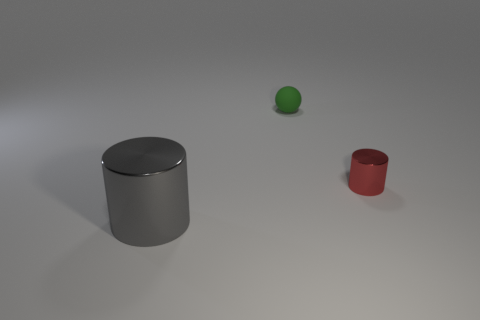What is the shape of the green matte object that is the same size as the red cylinder?
Provide a succinct answer. Sphere. The tiny thing that is the same material as the large cylinder is what color?
Your answer should be compact. Red. What is the size of the other gray metal thing that is the same shape as the small shiny thing?
Offer a very short reply. Large. Are there any other things that have the same size as the gray metal cylinder?
Ensure brevity in your answer.  No. There is a red thing; are there any green objects behind it?
Provide a short and direct response. Yes. Are there any other metallic objects of the same shape as the large gray metal object?
Your answer should be compact. Yes. What number of other objects are the same color as the big object?
Your response must be concise. 0. The shiny object that is to the left of the metal object that is behind the shiny object that is in front of the tiny metal thing is what color?
Your response must be concise. Gray. Is the number of large gray cylinders to the right of the small red metal cylinder the same as the number of small rubber cylinders?
Offer a very short reply. Yes. Do the metallic thing that is to the left of the green thing and the matte sphere have the same size?
Your answer should be very brief. No. 